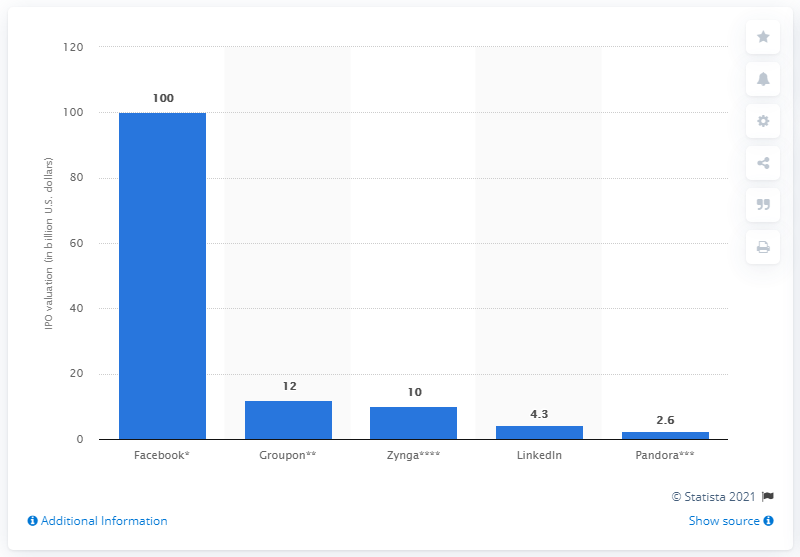Highlight a few significant elements in this photo. Pandora's initial public offering (IPO) was valued at $2.65 billion. 